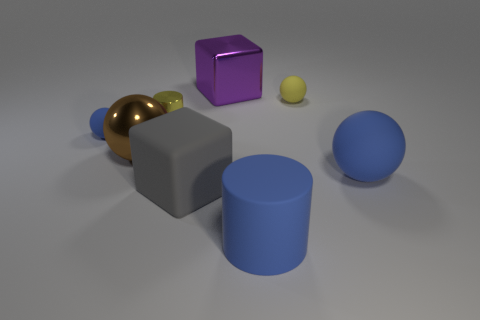Subtract all rubber spheres. How many spheres are left? 1 Add 2 rubber cylinders. How many objects exist? 10 Subtract all blue spheres. How many spheres are left? 2 Subtract all cylinders. How many objects are left? 6 Add 1 cylinders. How many cylinders are left? 3 Add 8 large gray rubber objects. How many large gray rubber objects exist? 9 Subtract 0 cyan balls. How many objects are left? 8 Subtract 1 spheres. How many spheres are left? 3 Subtract all purple balls. Subtract all yellow blocks. How many balls are left? 4 Subtract all red cylinders. How many gray cubes are left? 1 